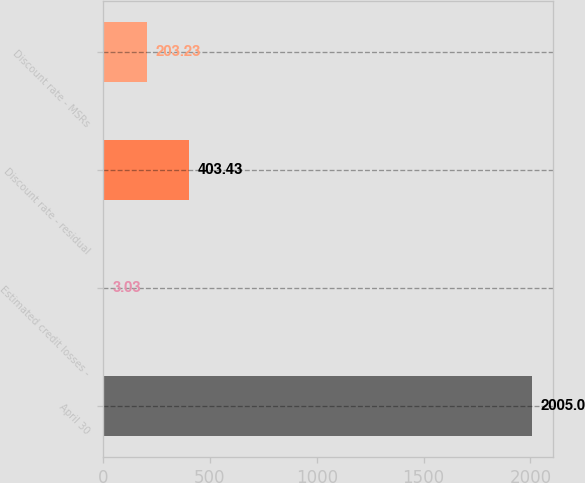Convert chart. <chart><loc_0><loc_0><loc_500><loc_500><bar_chart><fcel>April 30<fcel>Estimated credit losses -<fcel>Discount rate - residual<fcel>Discount rate - MSRs<nl><fcel>2005<fcel>3.03<fcel>403.43<fcel>203.23<nl></chart> 